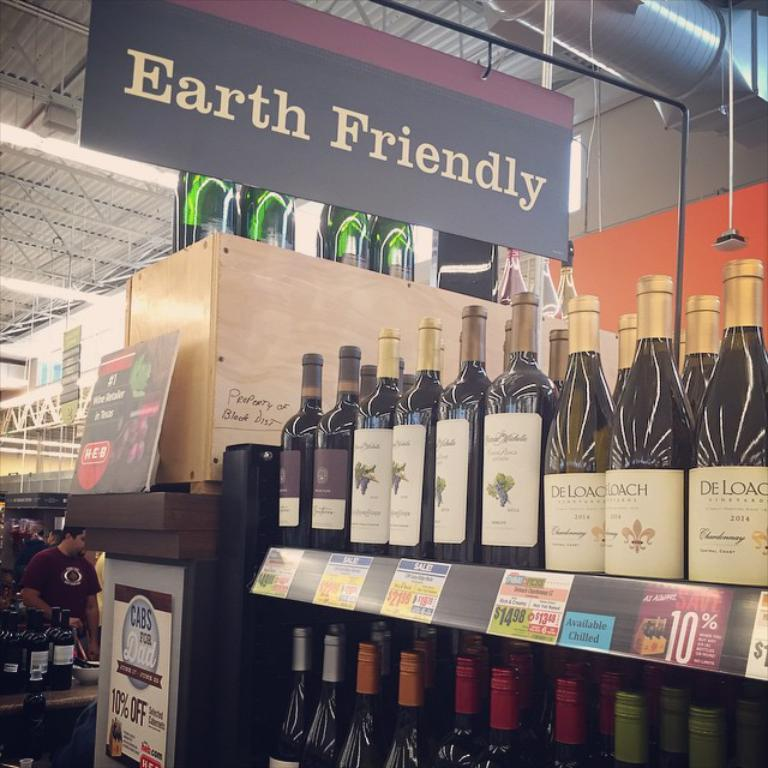Provide a one-sentence caption for the provided image. A store selling wine has a sign from the ceiling says, Earth Friendly.". 